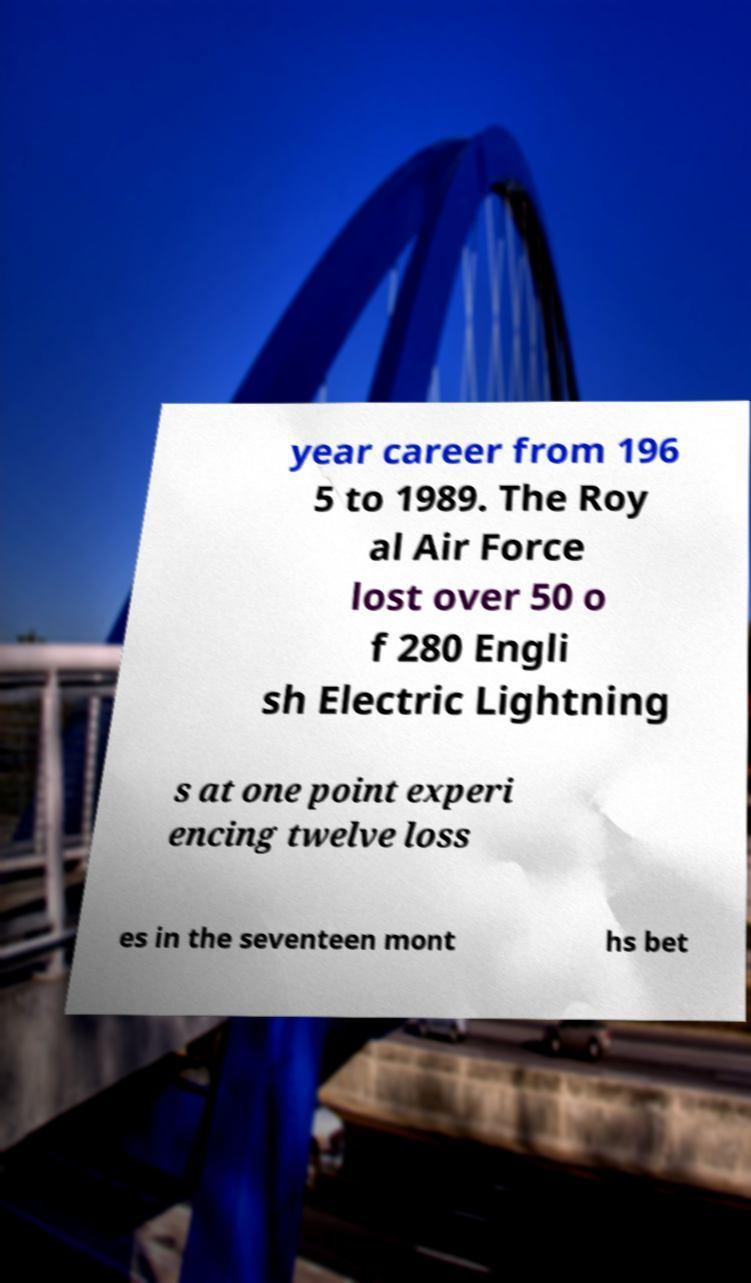I need the written content from this picture converted into text. Can you do that? year career from 196 5 to 1989. The Roy al Air Force lost over 50 o f 280 Engli sh Electric Lightning s at one point experi encing twelve loss es in the seventeen mont hs bet 